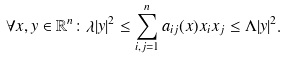Convert formula to latex. <formula><loc_0><loc_0><loc_500><loc_500>\forall x , y \in { \mathbb { R } } ^ { n } \colon \lambda | y | ^ { 2 } \leq \sum _ { i , j = 1 } ^ { n } a _ { i j } ( x ) x _ { i } x _ { j } \leq \Lambda | y | ^ { 2 } .</formula> 